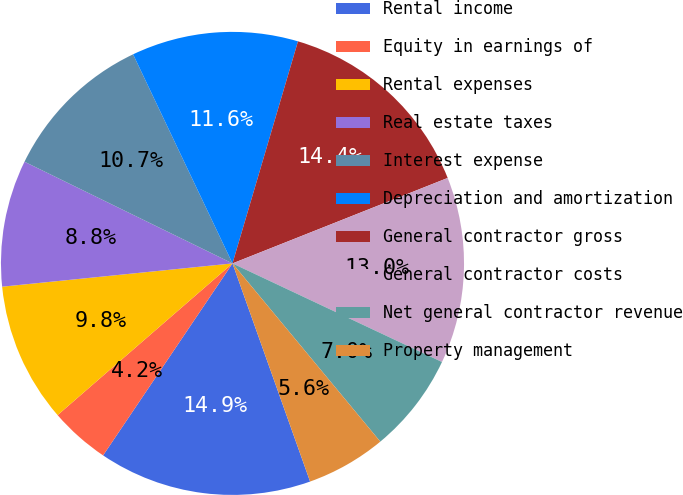Convert chart to OTSL. <chart><loc_0><loc_0><loc_500><loc_500><pie_chart><fcel>Rental income<fcel>Equity in earnings of<fcel>Rental expenses<fcel>Real estate taxes<fcel>Interest expense<fcel>Depreciation and amortization<fcel>General contractor gross<fcel>General contractor costs<fcel>Net general contractor revenue<fcel>Property management<nl><fcel>14.88%<fcel>4.19%<fcel>9.77%<fcel>8.84%<fcel>10.7%<fcel>11.63%<fcel>14.42%<fcel>13.02%<fcel>6.98%<fcel>5.58%<nl></chart> 